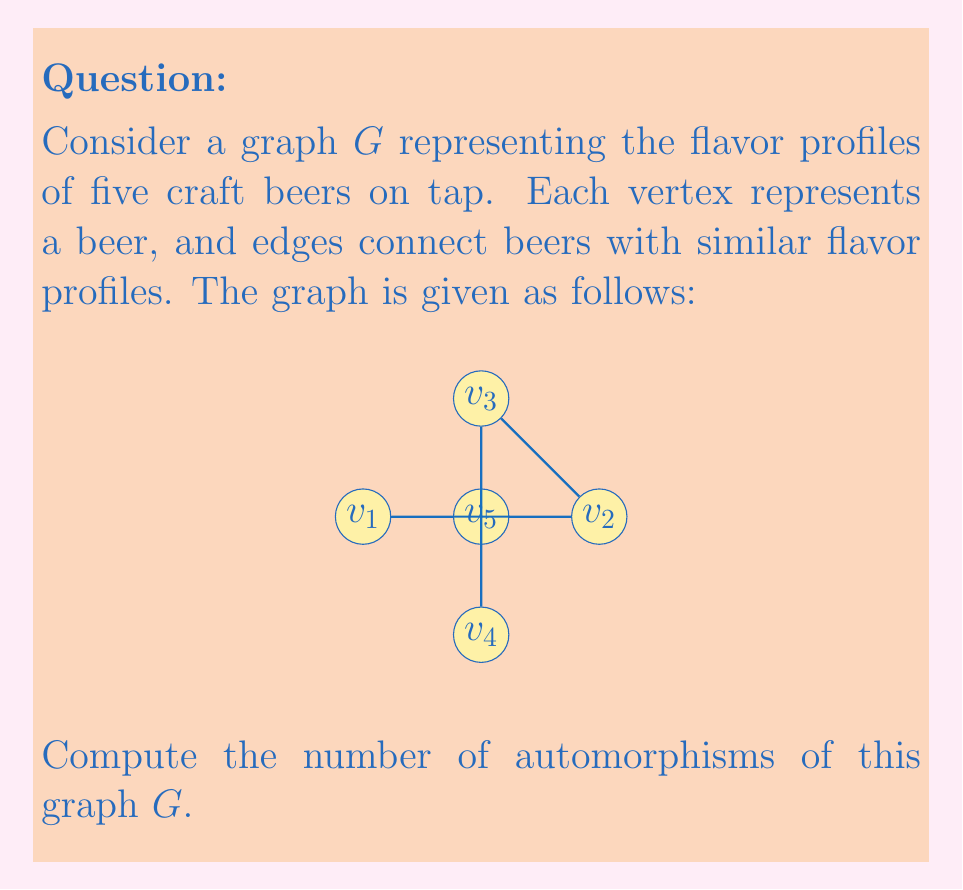Show me your answer to this math problem. To solve this problem, we need to follow these steps:

1) First, let's understand what an automorphism of a graph is. An automorphism is a permutation of the vertices that preserves adjacency. In other words, if two vertices are connected by an edge, their images under the automorphism must also be connected.

2) Now, let's analyze the structure of our graph:
   - It's a wheel graph with 5 vertices.
   - $v_5$ is the central vertex, connected to all other vertices.
   - $v_1$, $v_2$, $v_3$, and $v_4$ form a cycle around $v_5$.

3) Any automorphism must map $v_5$ to itself, as it's the only vertex with degree 4.

4) The remaining vertices can be permuted in any way that preserves the cycle structure. This is equivalent to the rotations and reflections of a square.

5) The symmetries of a square are:
   - 4 rotations (including the identity)
   - 4 reflections (2 diagonal, 2 axial)

6) Therefore, the total number of automorphisms is 8.

We can represent these automorphisms algebraically as permutations:

- Identity: $(1)(2)(3)(4)(5)$
- Rotations: $(1234)(5)$, $(13)(24)(5)$, $(1432)(5)$
- Reflections: $(14)(23)(5)$, $(12)(34)(5)$, $(13)(2)(4)(5)$, $(1)(3)(24)(5)$

Each of these permutations preserves the adjacency structure of the graph.
Answer: The number of automorphisms of the given graph $G$ is 8. 